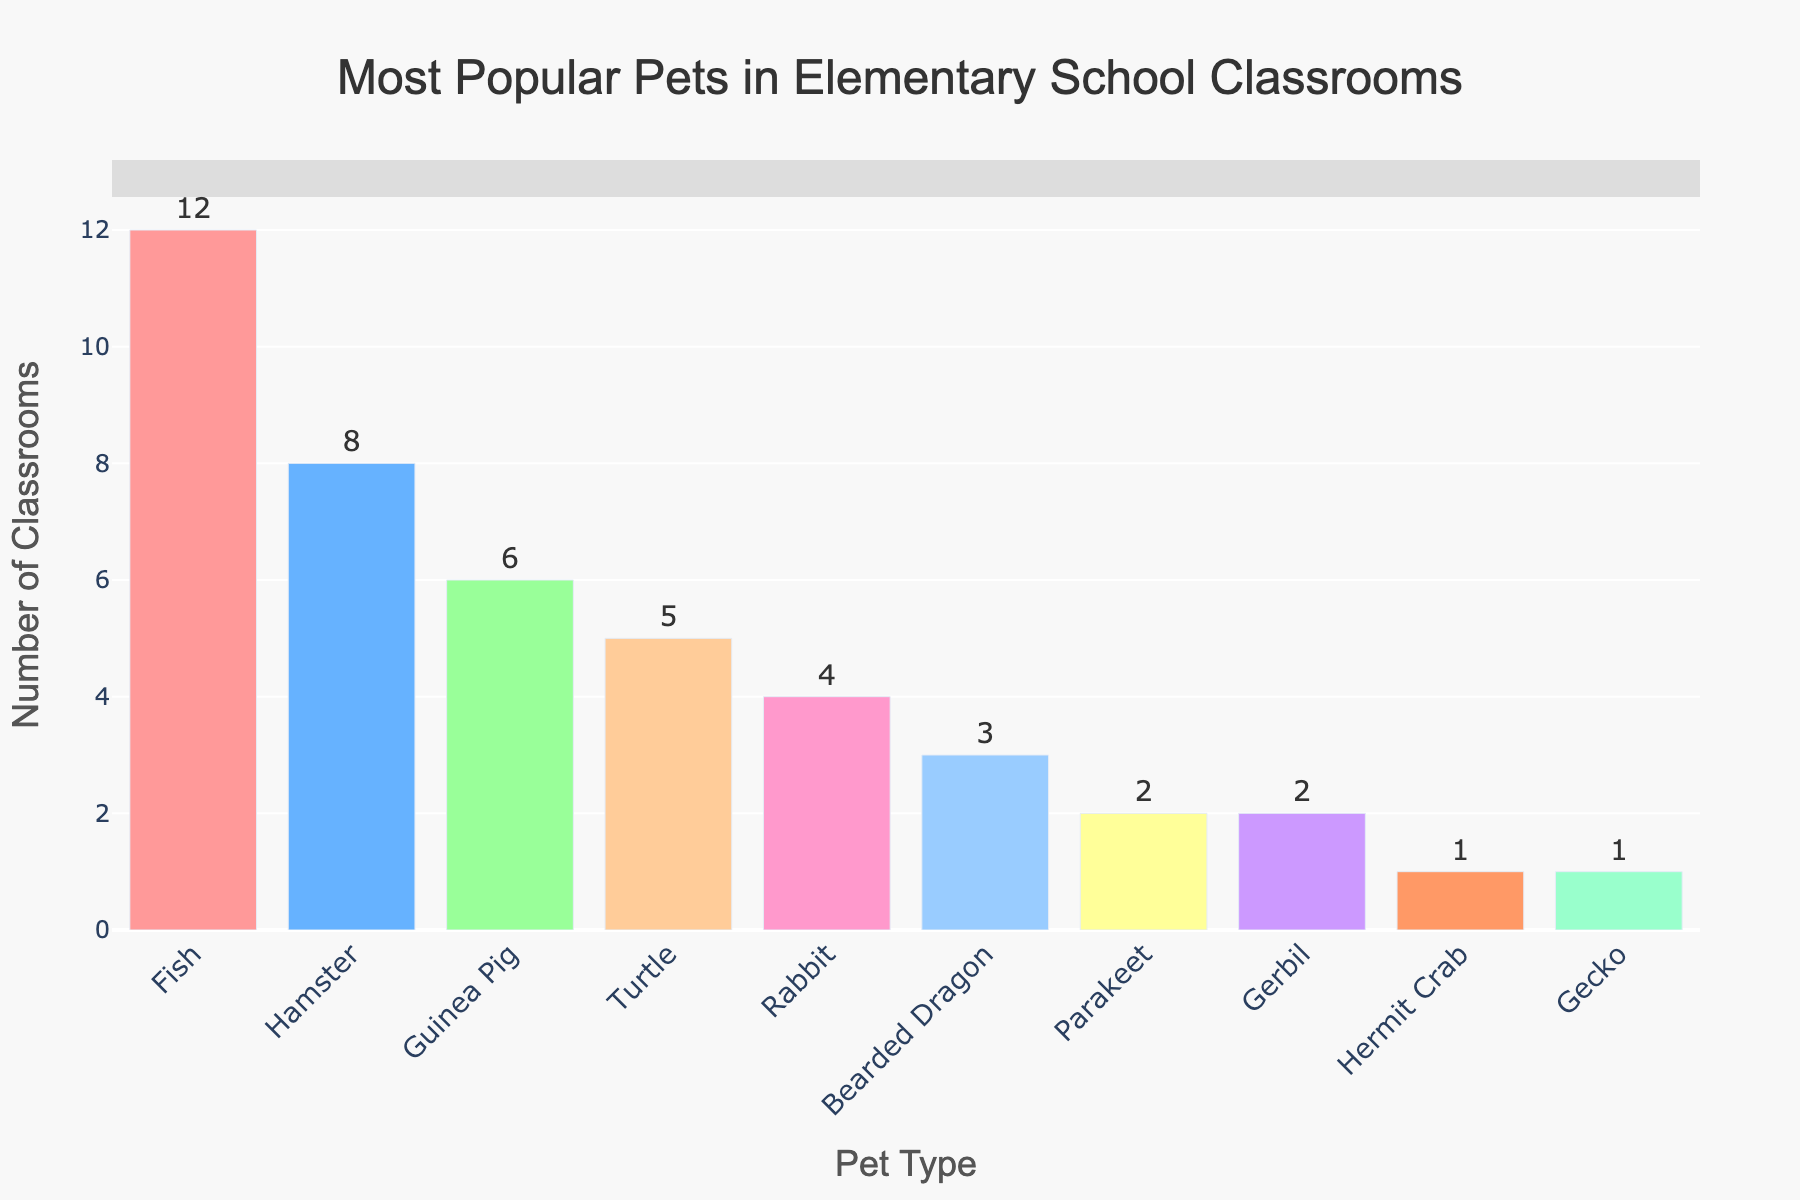Which pet is the most popular in elementary school classrooms? Look at the height of each bar in the bar chart. The tallest bar represents the most popular pet. In this case, the bar for "Fish" is the tallest.
Answer: Fish Which pet is less popular, Parakeet or Bearded Dragon? To find out which pet is less popular, compare the heights of the bars for Parakeet and Bearded Dragon. The Parakeet bar is shorter than the Bearded Dragon bar.
Answer: Parakeet How many classrooms have either Hamsters or Guinea Pigs? First, find the number of classrooms for Hamsters (8) and Guinea Pigs (6). Then add them together: 8 + 6.
Answer: 14 What is the difference in the number of classrooms between the most popular and least popular pets? Identify the most popular pet (Fish with 12 classrooms) and the least popular pets (Gecko and Hermit Crab with 1 classroom each). Subtract the smaller value from the larger value: 12 - 1.
Answer: 11 What is the total number of classrooms that have either Turtles, Rabbits, or Bearded Dragons? Find the number of classrooms for each pet: Turtles (5), Rabbits (4), Bearded Dragons (3). Add these numbers together: 5 + 4 + 3.
Answer: 12 Which pet is more popular, a Rabbit or a Turtle, and by how much? Compare the number of classrooms for Rabbits (4) and Turtles (5). The Turtle is more popular by the difference: 5 - 4.
Answer: Turtle by 1 What is the average number of classrooms for the top three most popular pets? Identify the top three pets (Fish - 12, Hamster - 8, Guinea Pig - 6). Add these numbers together: 12 + 8 + 6 = 26. Divide by 3 (the number of pets): 26 / 3.
Answer: Approximately 8.67 How many more classrooms have Fish compared to Gerbils? Look at the number of classrooms for Fish (12) and Gerbils (2). Subtract the smaller value from the larger value: 12 - 2.
Answer: 10 